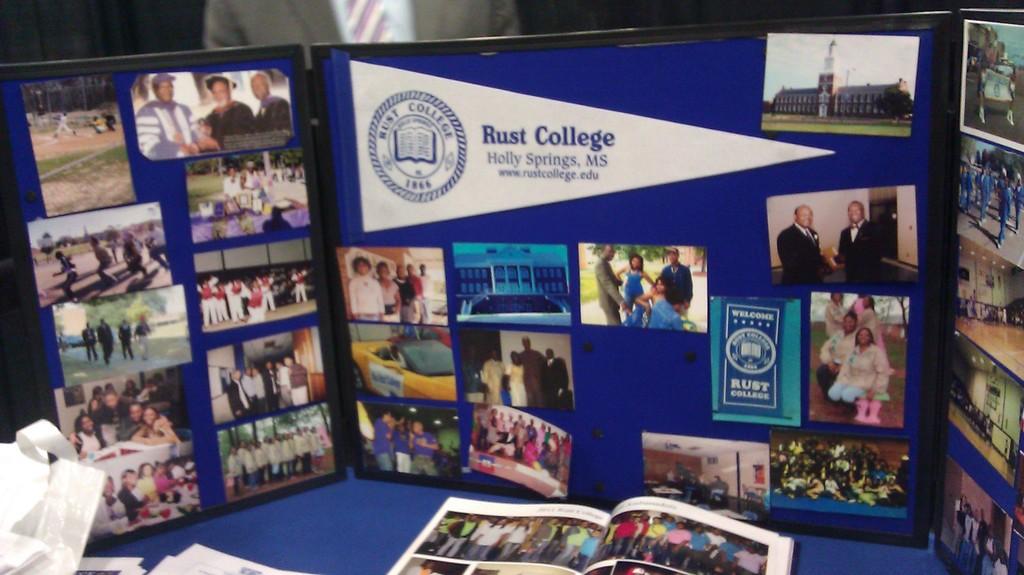What is the name of the college shown?
Give a very brief answer. Rust college. 